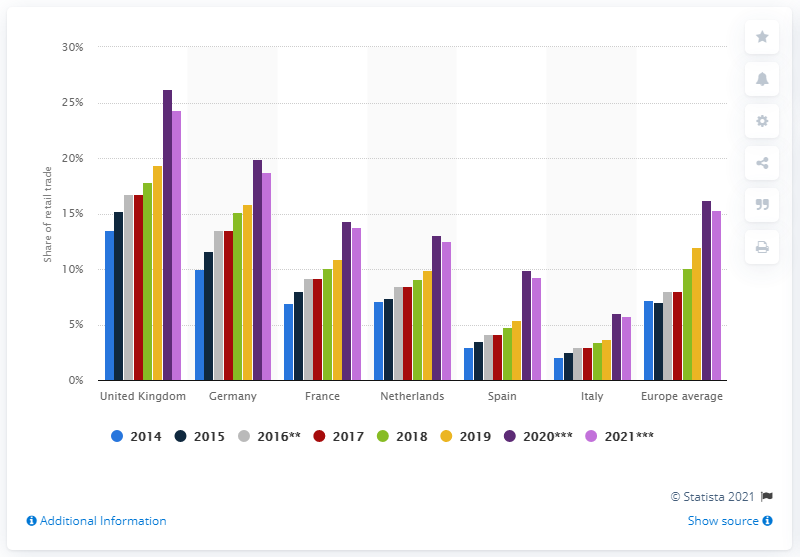Identify some key points in this picture. In each year, the United Kingdom led the country comparison. 